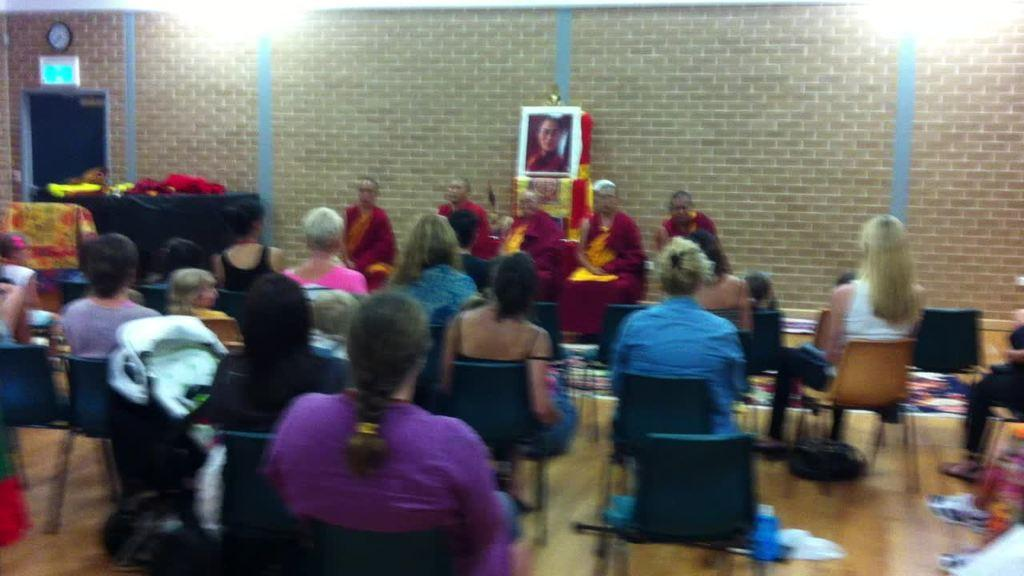What are the people in the image doing? The people in the image are sitting on cars. What can be seen on the floor in the image? There are objects on the floor in the image. What can be seen on the table in the image? There are objects on a table in the image. What is on the wall in the image? There is a photo frame, a clock, and a board on the wall in the image. What type of celery is being used as a decoration on the board in the image? There is no celery present in the image; it is a board on the wall with no visible decorations. What nation is represented by the people sitting on the cars in the image? The image does not provide information about the nationality of the people sitting on the cars. 